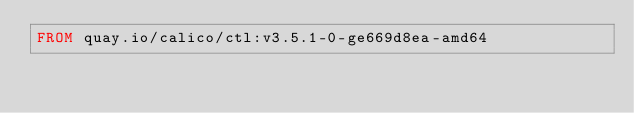Convert code to text. <code><loc_0><loc_0><loc_500><loc_500><_Dockerfile_>FROM quay.io/calico/ctl:v3.5.1-0-ge669d8ea-amd64
</code> 